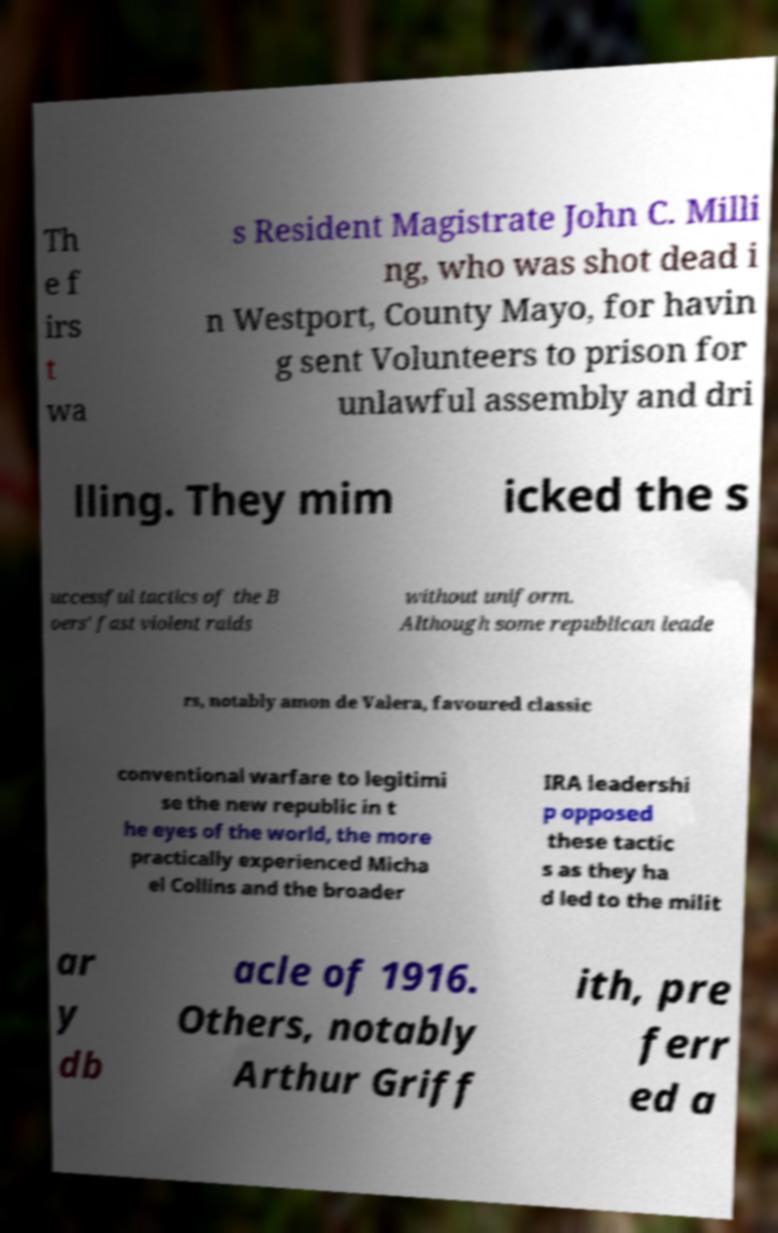I need the written content from this picture converted into text. Can you do that? Th e f irs t wa s Resident Magistrate John C. Milli ng, who was shot dead i n Westport, County Mayo, for havin g sent Volunteers to prison for unlawful assembly and dri lling. They mim icked the s uccessful tactics of the B oers' fast violent raids without uniform. Although some republican leade rs, notably amon de Valera, favoured classic conventional warfare to legitimi se the new republic in t he eyes of the world, the more practically experienced Micha el Collins and the broader IRA leadershi p opposed these tactic s as they ha d led to the milit ar y db acle of 1916. Others, notably Arthur Griff ith, pre ferr ed a 